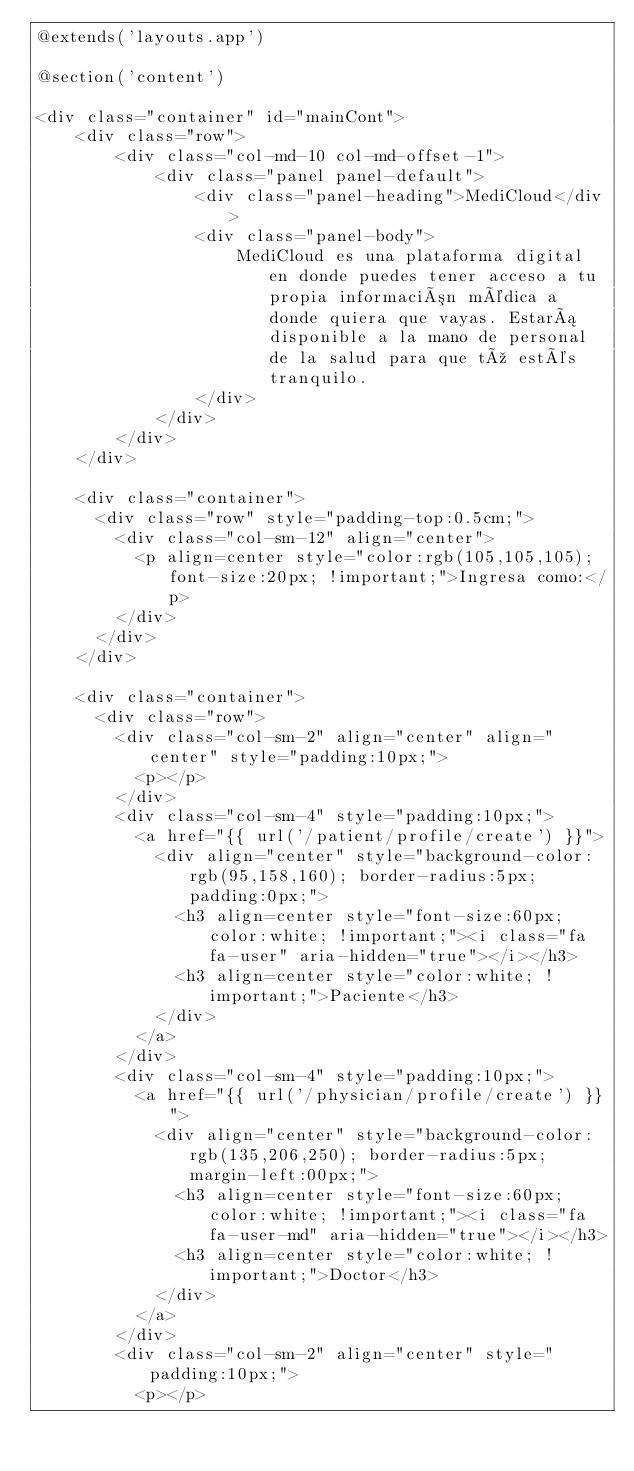Convert code to text. <code><loc_0><loc_0><loc_500><loc_500><_PHP_>@extends('layouts.app')

@section('content')

<div class="container" id="mainCont">
    <div class="row">
        <div class="col-md-10 col-md-offset-1">
            <div class="panel panel-default">
                <div class="panel-heading">MediCloud</div>
                <div class="panel-body">
                    MediCloud es una plataforma digital en donde puedes tener acceso a tu propia información médica a donde quiera que vayas. Estará disponible a la mano de personal de la salud para que tú estés tranquilo.
                </div>
            </div>
        </div>
    </div>

    <div class="container">
      <div class="row" style="padding-top:0.5cm;">
        <div class="col-sm-12" align="center">
          <p align=center style="color:rgb(105,105,105); font-size:20px; !important;">Ingresa como:</p>
        </div>
      </div>
    </div>

    <div class="container">
      <div class="row">
        <div class="col-sm-2" align="center" align="center" style="padding:10px;">
          <p></p>
        </div>
        <div class="col-sm-4" style="padding:10px;">
          <a href="{{ url('/patient/profile/create') }}">
            <div align="center" style="background-color:rgb(95,158,160); border-radius:5px; padding:0px;">
              <h3 align=center style="font-size:60px; color:white; !important;"><i class="fa fa-user" aria-hidden="true"></i></h3>
              <h3 align=center style="color:white; !important;">Paciente</h3>
            </div>  
          </a>  
        </div>
        <div class="col-sm-4" style="padding:10px;">
          <a href="{{ url('/physician/profile/create') }}">
            <div align="center" style="background-color:rgb(135,206,250); border-radius:5px; margin-left:00px;">
              <h3 align=center style="font-size:60px; color:white; !important;"><i class="fa fa-user-md" aria-hidden="true"></i></h3>
              <h3 align=center style="color:white; !important;">Doctor</h3>
            </div>
          </a>
        </div>
        <div class="col-sm-2" align="center" style="padding:10px;">
          <p></p></code> 